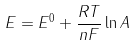<formula> <loc_0><loc_0><loc_500><loc_500>E = E ^ { 0 } + \frac { R T } { n F } \ln A</formula> 